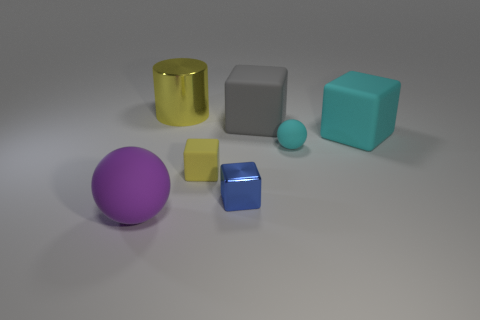Which object in the image appears to have the smoothest surface? The yellow cylinder seems to have the smoothest surface, reflecting light uniformly and indicating a very smooth texture. 